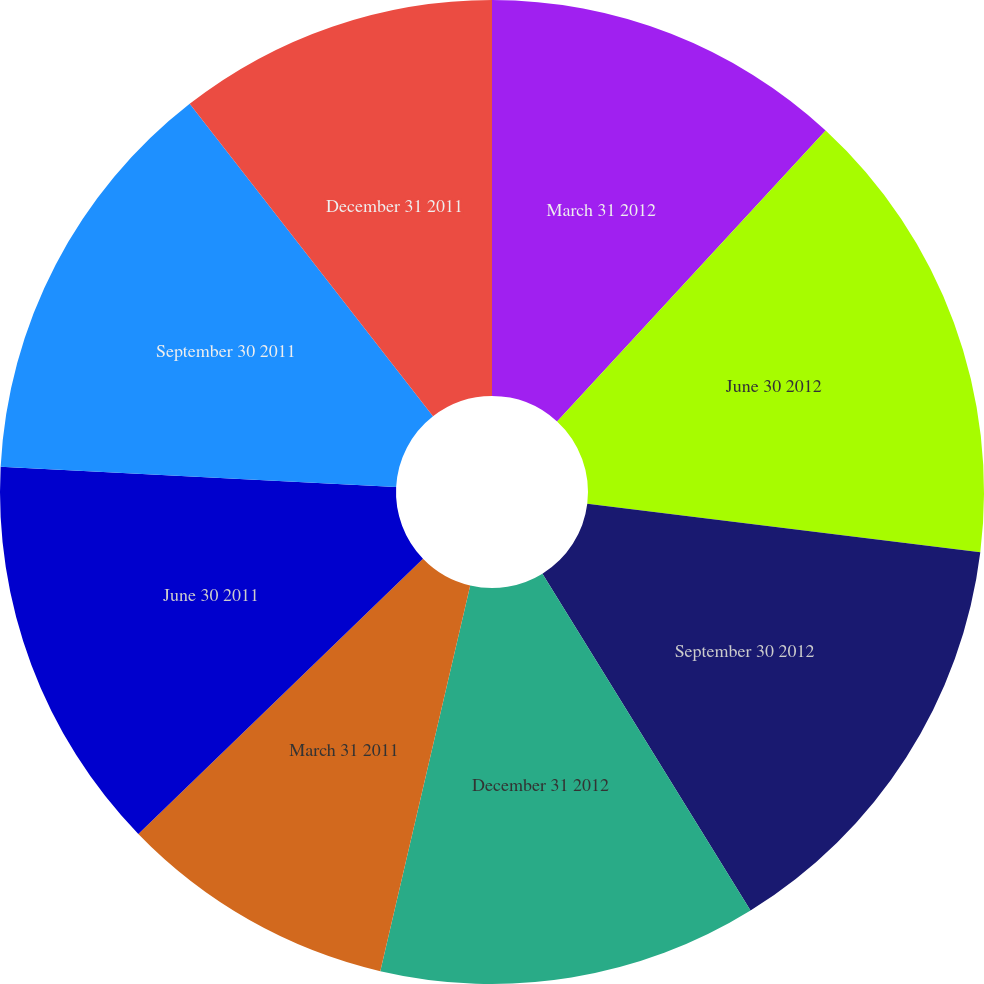<chart> <loc_0><loc_0><loc_500><loc_500><pie_chart><fcel>March 31 2012<fcel>June 30 2012<fcel>September 30 2012<fcel>December 31 2012<fcel>March 31 2011<fcel>June 30 2011<fcel>September 30 2011<fcel>December 31 2011<nl><fcel>11.86%<fcel>15.09%<fcel>14.24%<fcel>12.45%<fcel>9.12%<fcel>13.05%<fcel>13.65%<fcel>10.53%<nl></chart> 